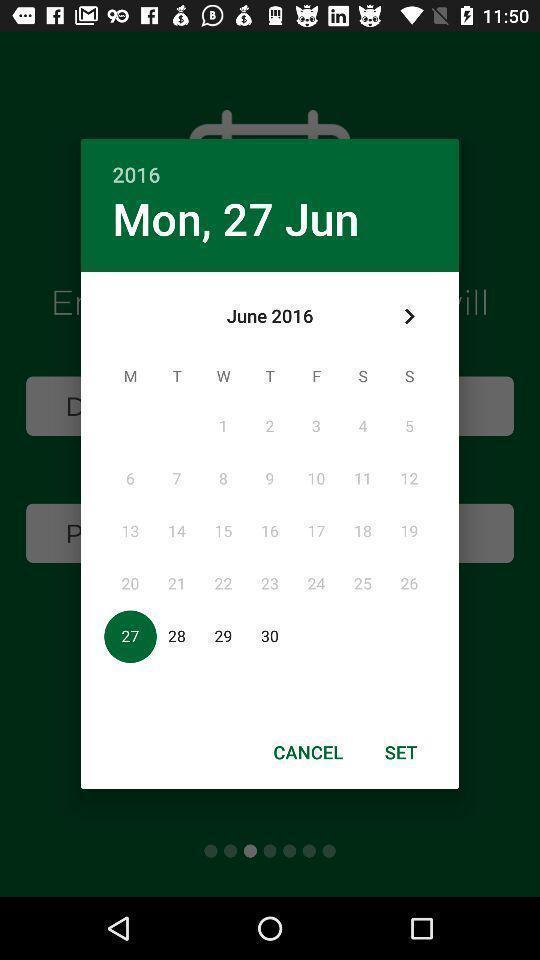Please provide a description for this image. Pop-up showing options to set the date. 